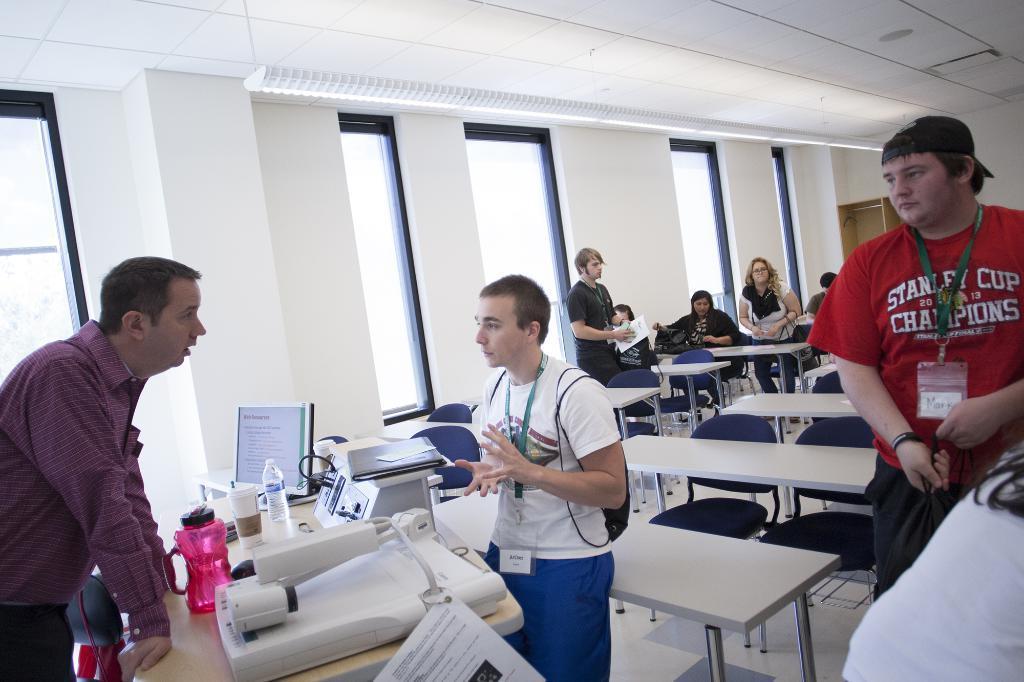How would you summarize this image in a sentence or two? A teacher is explaining something to a student with few other students in the classroom. 